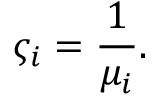Convert formula to latex. <formula><loc_0><loc_0><loc_500><loc_500>\varsigma _ { i } = \frac { 1 } { \mu _ { i } } .</formula> 